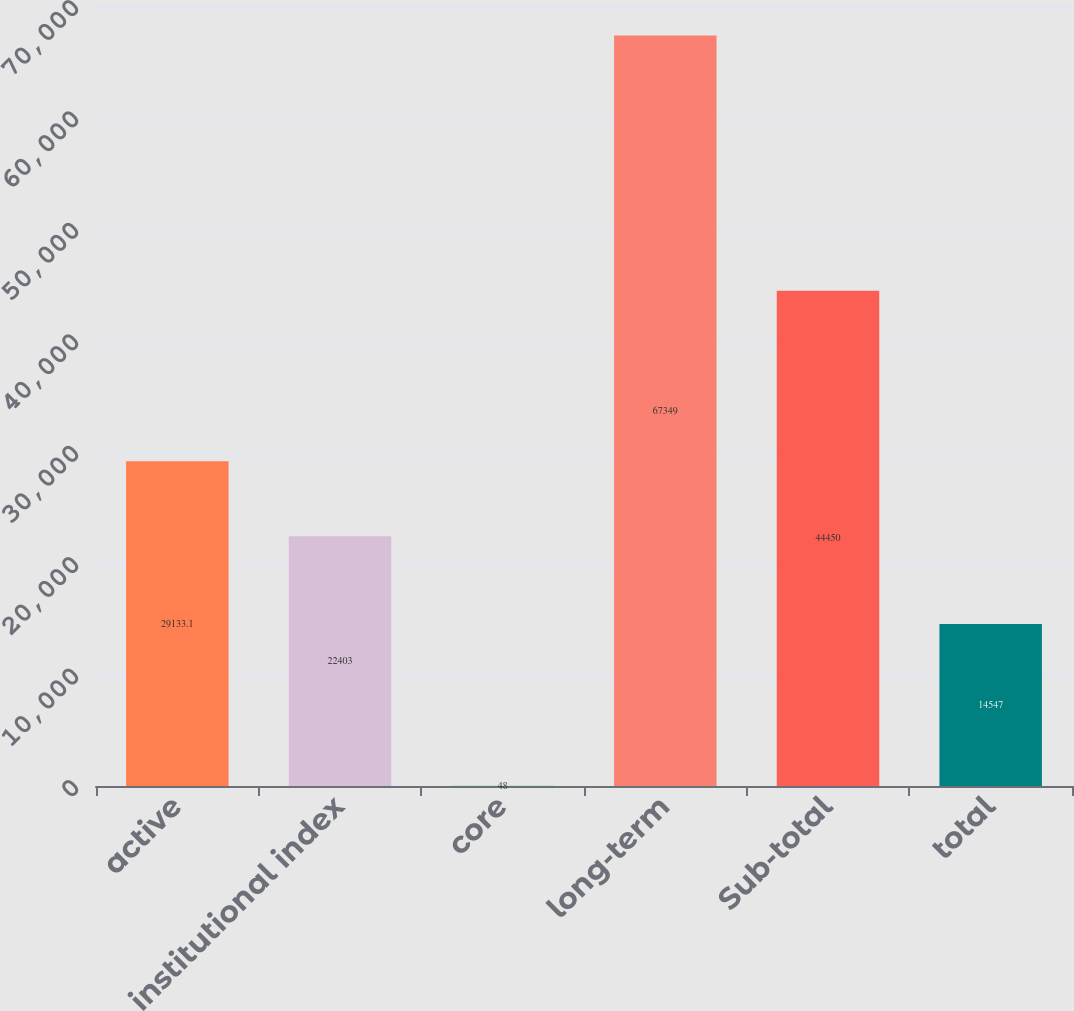<chart> <loc_0><loc_0><loc_500><loc_500><bar_chart><fcel>active<fcel>institutional index<fcel>core<fcel>long-term<fcel>Sub-total<fcel>total<nl><fcel>29133.1<fcel>22403<fcel>48<fcel>67349<fcel>44450<fcel>14547<nl></chart> 